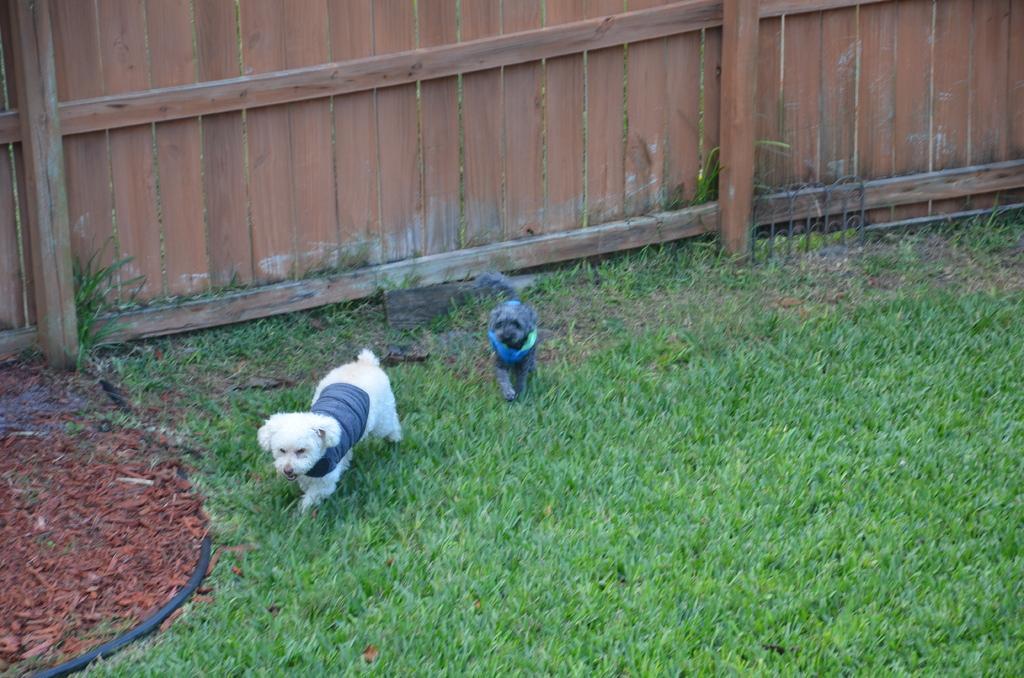Please provide a concise description of this image. In the center of the image we can see two dogs, grass and one black color object. In the background there is a wooden fence. 